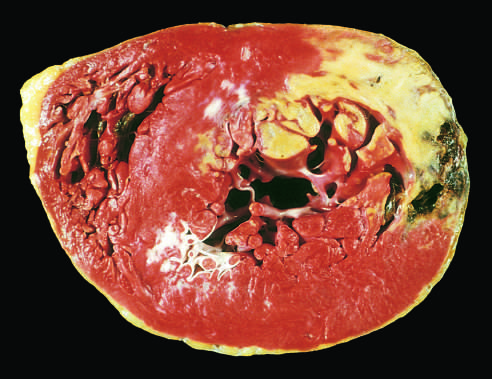s the absence of staining due to enzyme leakage after cell death?
Answer the question using a single word or phrase. Yes 